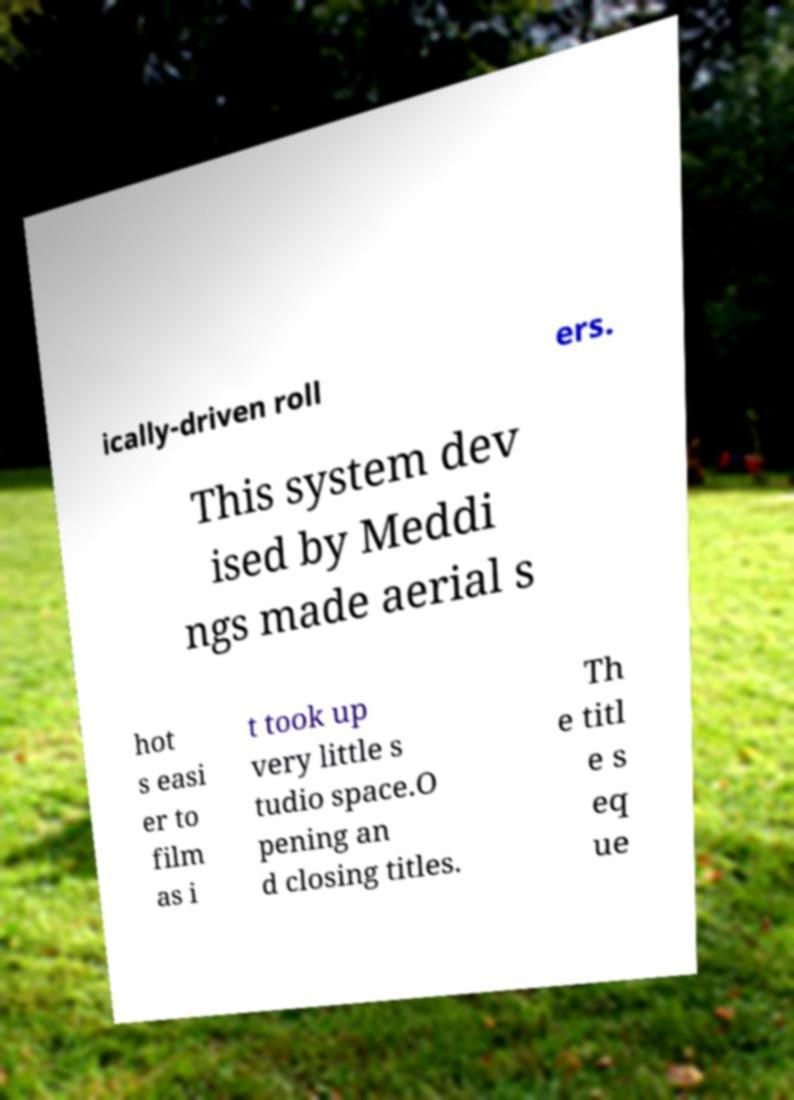There's text embedded in this image that I need extracted. Can you transcribe it verbatim? ically-driven roll ers. This system dev ised by Meddi ngs made aerial s hot s easi er to film as i t took up very little s tudio space.O pening an d closing titles. Th e titl e s eq ue 